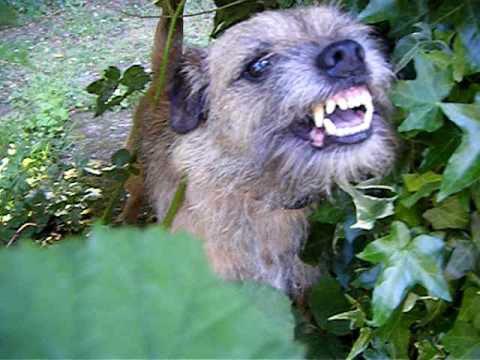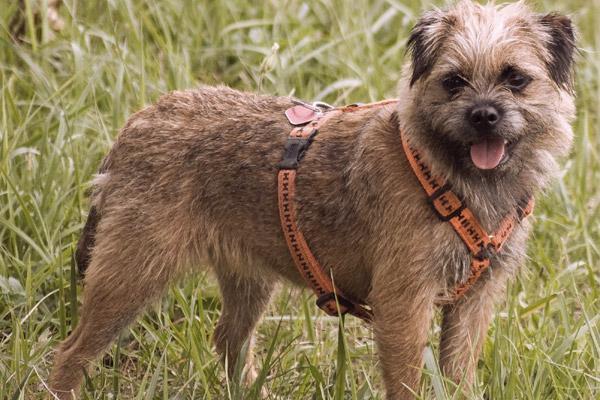The first image is the image on the left, the second image is the image on the right. For the images displayed, is the sentence "There is exactly one dog in every photo and no dogs have their mouths open." factually correct? Answer yes or no. No. The first image is the image on the left, the second image is the image on the right. For the images shown, is this caption "The right image contains one dog standing in the grass with its tail hanging down, its mouth open, and something around its neck." true? Answer yes or no. Yes. 